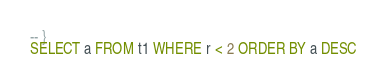Convert code to text. <code><loc_0><loc_0><loc_500><loc_500><_SQL_>-- }
SELECT a FROM t1 WHERE r < 2 ORDER BY a DESC</code> 